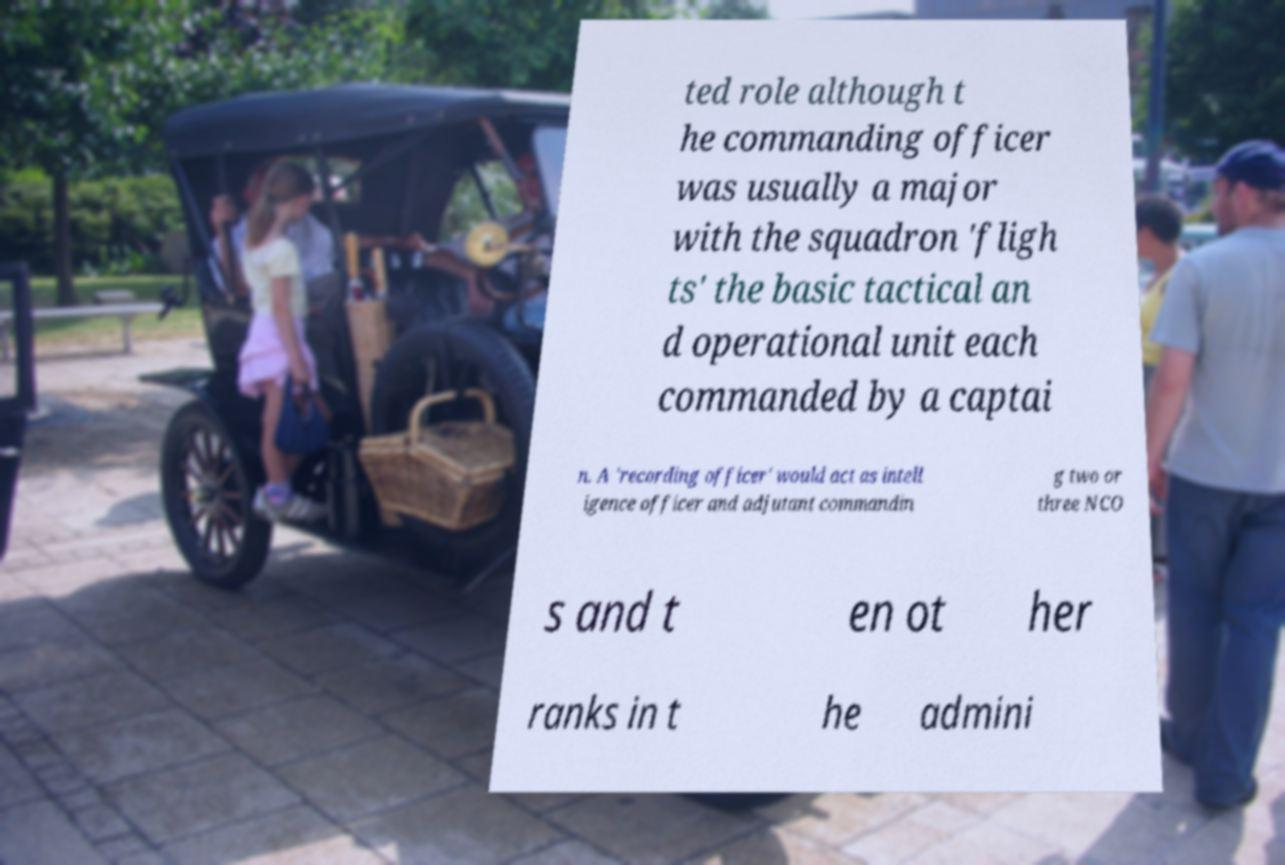Could you extract and type out the text from this image? ted role although t he commanding officer was usually a major with the squadron 'fligh ts' the basic tactical an d operational unit each commanded by a captai n. A 'recording officer' would act as intell igence officer and adjutant commandin g two or three NCO s and t en ot her ranks in t he admini 